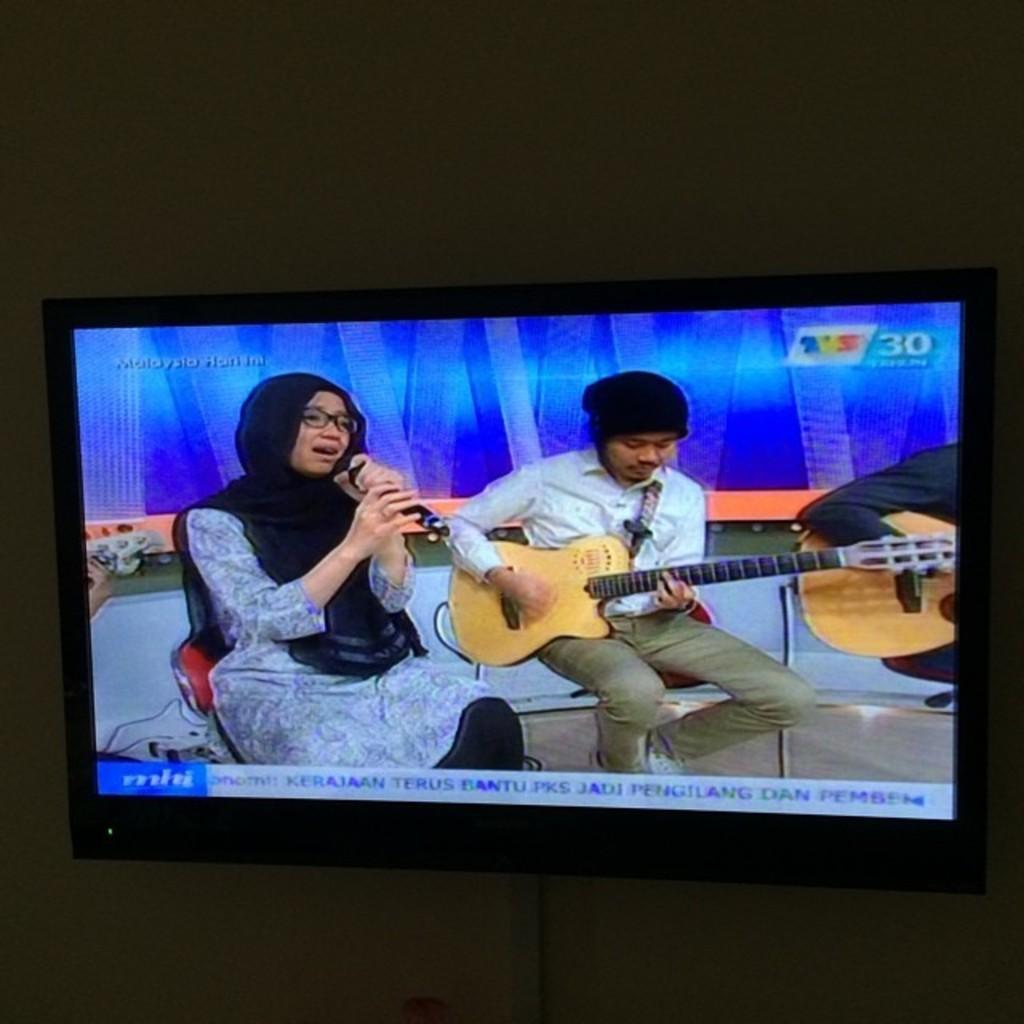Please provide a concise description of this image. In this picture I can see a television attached to the wall, there are three persons sitting on the chairs, a person holding a mike, two persons holding the guitars, and there are numbers and words, on the screen of the television. 